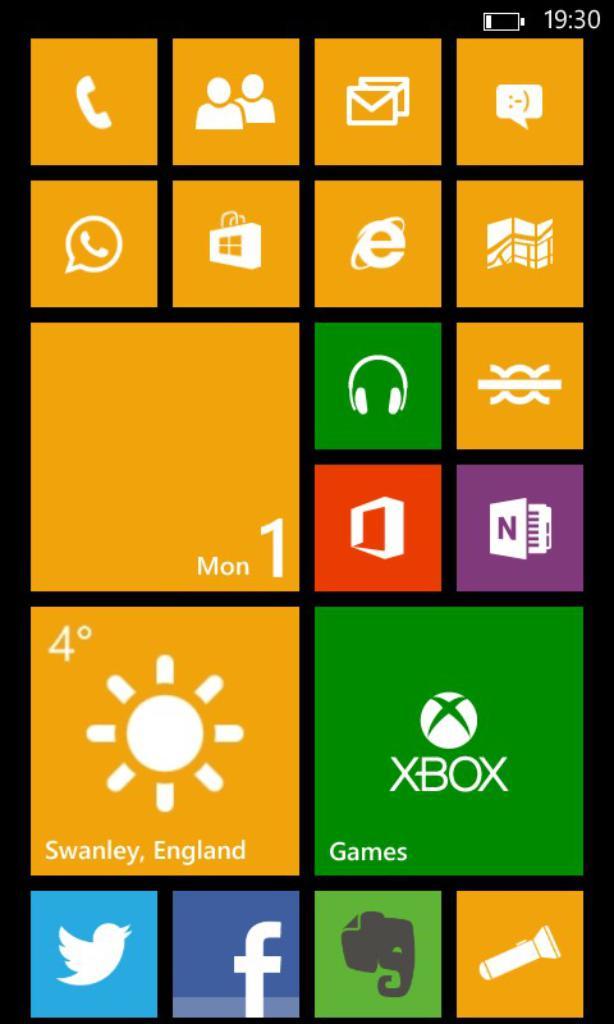What day is it?
Ensure brevity in your answer.  Monday. What is the temperature?
Provide a succinct answer. 4. 